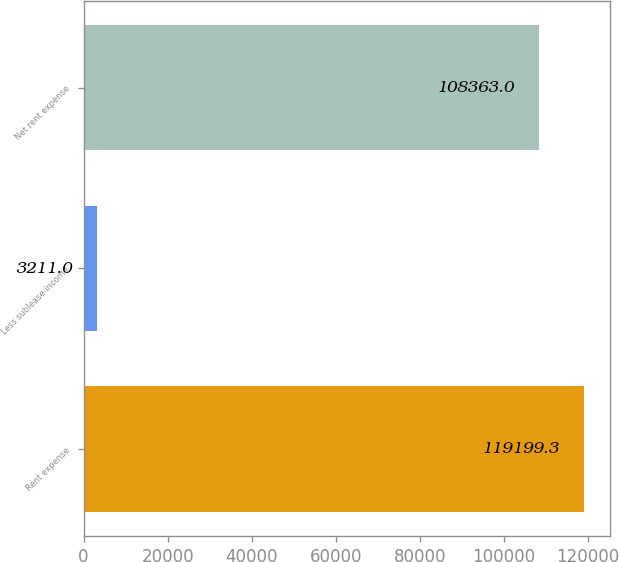Convert chart. <chart><loc_0><loc_0><loc_500><loc_500><bar_chart><fcel>Rent expense<fcel>Less sublease income<fcel>Net rent expense<nl><fcel>119199<fcel>3211<fcel>108363<nl></chart> 